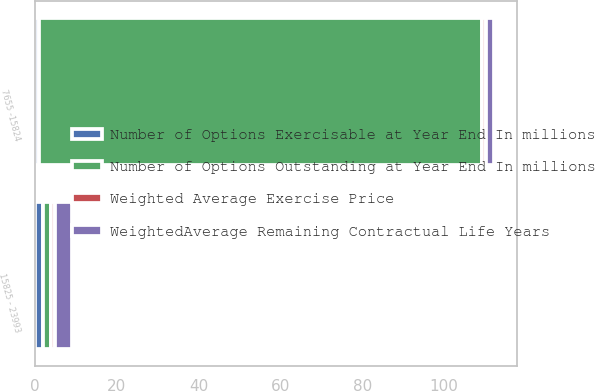Convert chart to OTSL. <chart><loc_0><loc_0><loc_500><loc_500><stacked_bar_chart><ecel><fcel>7655 -15824<fcel>15825 - 23993<nl><fcel>Number of Options Exercisable at Year End In millions<fcel>1<fcel>2<nl><fcel>WeightedAverage Remaining Contractual Life Years<fcel>2<fcel>4<nl><fcel>Number of Options Outstanding at Year End In millions<fcel>108.17<fcel>2<nl><fcel>Weighted Average Exercise Price<fcel>1<fcel>1<nl></chart> 